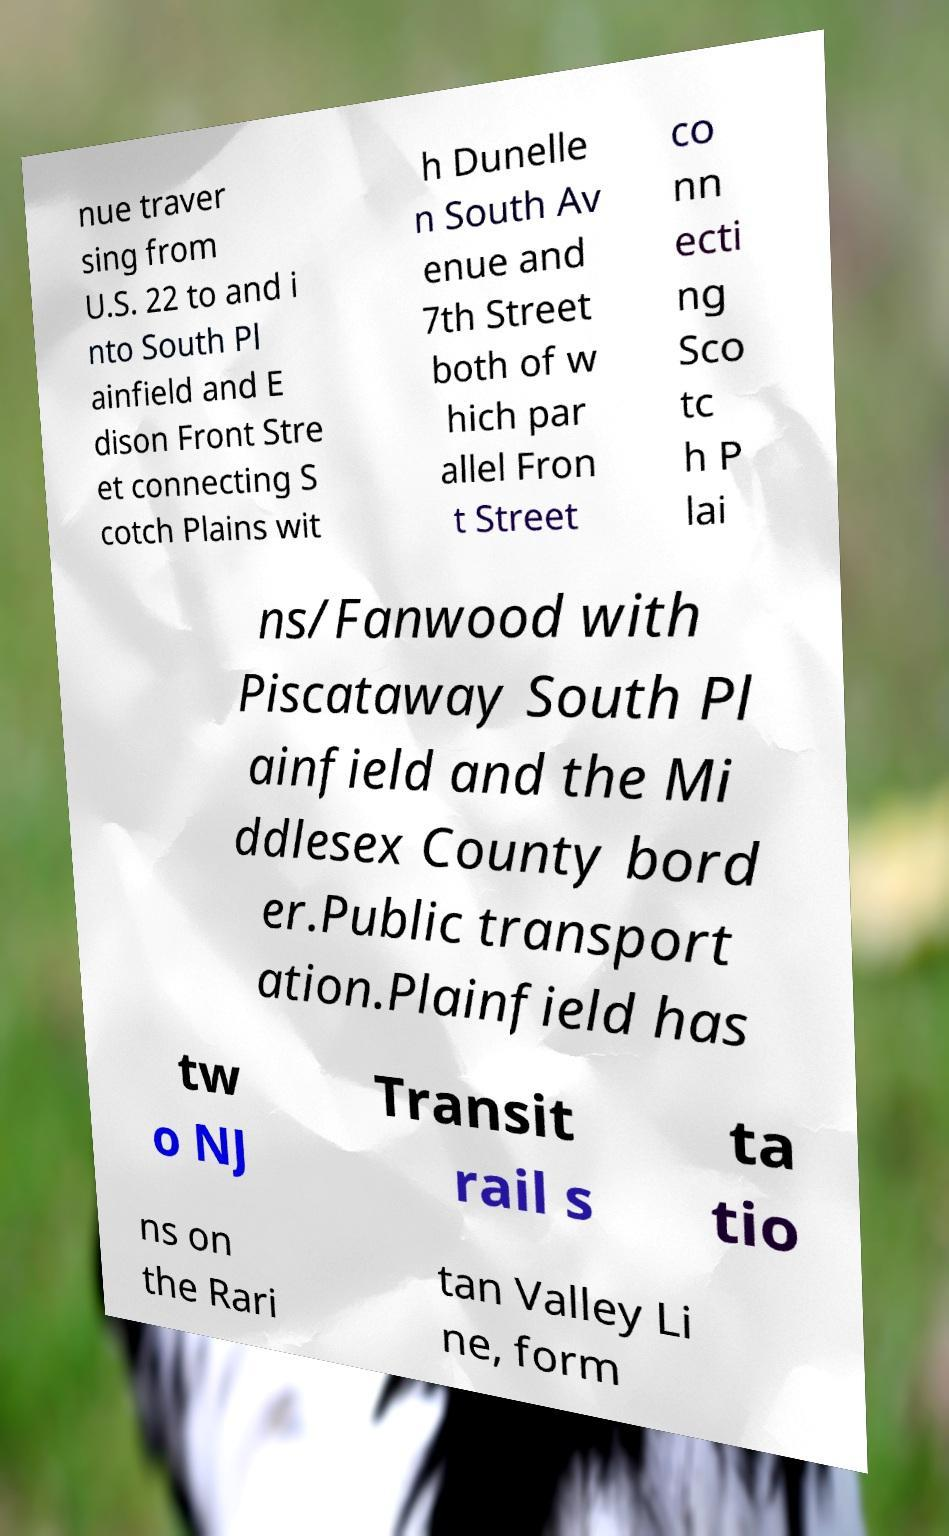There's text embedded in this image that I need extracted. Can you transcribe it verbatim? nue traver sing from U.S. 22 to and i nto South Pl ainfield and E dison Front Stre et connecting S cotch Plains wit h Dunelle n South Av enue and 7th Street both of w hich par allel Fron t Street co nn ecti ng Sco tc h P lai ns/Fanwood with Piscataway South Pl ainfield and the Mi ddlesex County bord er.Public transport ation.Plainfield has tw o NJ Transit rail s ta tio ns on the Rari tan Valley Li ne, form 